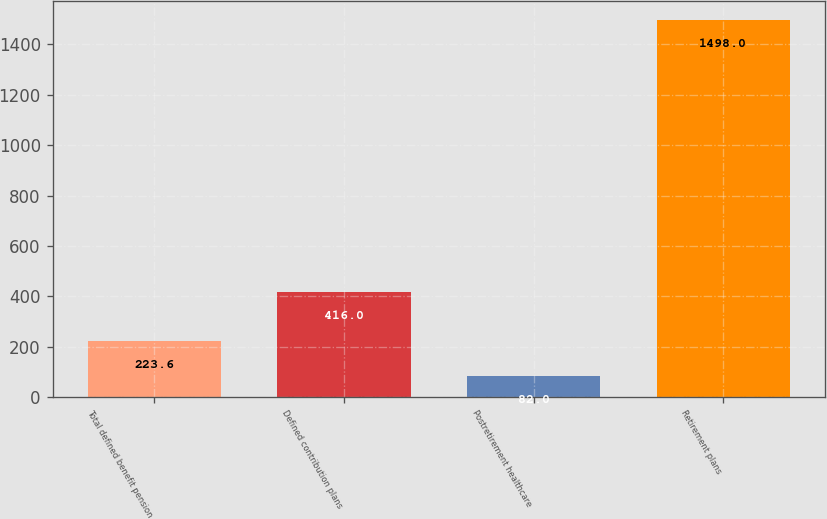<chart> <loc_0><loc_0><loc_500><loc_500><bar_chart><fcel>Total defined benefit pension<fcel>Defined contribution plans<fcel>Postretirement healthcare<fcel>Retirement plans<nl><fcel>223.6<fcel>416<fcel>82<fcel>1498<nl></chart> 